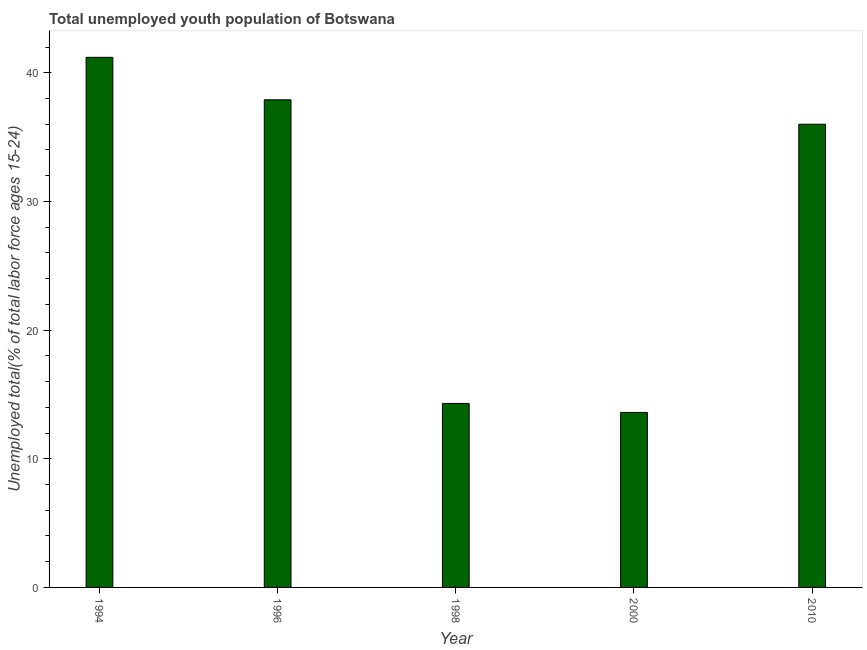Does the graph contain grids?
Provide a succinct answer. No. What is the title of the graph?
Your answer should be compact. Total unemployed youth population of Botswana. What is the label or title of the X-axis?
Offer a terse response. Year. What is the label or title of the Y-axis?
Provide a succinct answer. Unemployed total(% of total labor force ages 15-24). What is the unemployed youth in 2000?
Offer a very short reply. 13.6. Across all years, what is the maximum unemployed youth?
Your answer should be very brief. 41.2. Across all years, what is the minimum unemployed youth?
Make the answer very short. 13.6. In which year was the unemployed youth minimum?
Your answer should be compact. 2000. What is the sum of the unemployed youth?
Ensure brevity in your answer.  143. What is the difference between the unemployed youth in 1996 and 1998?
Provide a short and direct response. 23.6. What is the average unemployed youth per year?
Ensure brevity in your answer.  28.6. What is the median unemployed youth?
Give a very brief answer. 36. In how many years, is the unemployed youth greater than 14 %?
Provide a short and direct response. 4. What is the ratio of the unemployed youth in 1996 to that in 2010?
Your answer should be compact. 1.05. Is the sum of the unemployed youth in 1998 and 2010 greater than the maximum unemployed youth across all years?
Provide a succinct answer. Yes. What is the difference between the highest and the lowest unemployed youth?
Make the answer very short. 27.6. How many bars are there?
Your answer should be very brief. 5. Are all the bars in the graph horizontal?
Ensure brevity in your answer.  No. What is the difference between two consecutive major ticks on the Y-axis?
Your response must be concise. 10. What is the Unemployed total(% of total labor force ages 15-24) in 1994?
Your response must be concise. 41.2. What is the Unemployed total(% of total labor force ages 15-24) in 1996?
Keep it short and to the point. 37.9. What is the Unemployed total(% of total labor force ages 15-24) of 1998?
Make the answer very short. 14.3. What is the Unemployed total(% of total labor force ages 15-24) of 2000?
Make the answer very short. 13.6. What is the difference between the Unemployed total(% of total labor force ages 15-24) in 1994 and 1996?
Make the answer very short. 3.3. What is the difference between the Unemployed total(% of total labor force ages 15-24) in 1994 and 1998?
Your response must be concise. 26.9. What is the difference between the Unemployed total(% of total labor force ages 15-24) in 1994 and 2000?
Make the answer very short. 27.6. What is the difference between the Unemployed total(% of total labor force ages 15-24) in 1994 and 2010?
Keep it short and to the point. 5.2. What is the difference between the Unemployed total(% of total labor force ages 15-24) in 1996 and 1998?
Your answer should be very brief. 23.6. What is the difference between the Unemployed total(% of total labor force ages 15-24) in 1996 and 2000?
Make the answer very short. 24.3. What is the difference between the Unemployed total(% of total labor force ages 15-24) in 1996 and 2010?
Ensure brevity in your answer.  1.9. What is the difference between the Unemployed total(% of total labor force ages 15-24) in 1998 and 2000?
Make the answer very short. 0.7. What is the difference between the Unemployed total(% of total labor force ages 15-24) in 1998 and 2010?
Make the answer very short. -21.7. What is the difference between the Unemployed total(% of total labor force ages 15-24) in 2000 and 2010?
Your response must be concise. -22.4. What is the ratio of the Unemployed total(% of total labor force ages 15-24) in 1994 to that in 1996?
Offer a very short reply. 1.09. What is the ratio of the Unemployed total(% of total labor force ages 15-24) in 1994 to that in 1998?
Your response must be concise. 2.88. What is the ratio of the Unemployed total(% of total labor force ages 15-24) in 1994 to that in 2000?
Your answer should be compact. 3.03. What is the ratio of the Unemployed total(% of total labor force ages 15-24) in 1994 to that in 2010?
Offer a terse response. 1.14. What is the ratio of the Unemployed total(% of total labor force ages 15-24) in 1996 to that in 1998?
Provide a short and direct response. 2.65. What is the ratio of the Unemployed total(% of total labor force ages 15-24) in 1996 to that in 2000?
Your answer should be very brief. 2.79. What is the ratio of the Unemployed total(% of total labor force ages 15-24) in 1996 to that in 2010?
Keep it short and to the point. 1.05. What is the ratio of the Unemployed total(% of total labor force ages 15-24) in 1998 to that in 2000?
Your answer should be very brief. 1.05. What is the ratio of the Unemployed total(% of total labor force ages 15-24) in 1998 to that in 2010?
Ensure brevity in your answer.  0.4. What is the ratio of the Unemployed total(% of total labor force ages 15-24) in 2000 to that in 2010?
Your response must be concise. 0.38. 